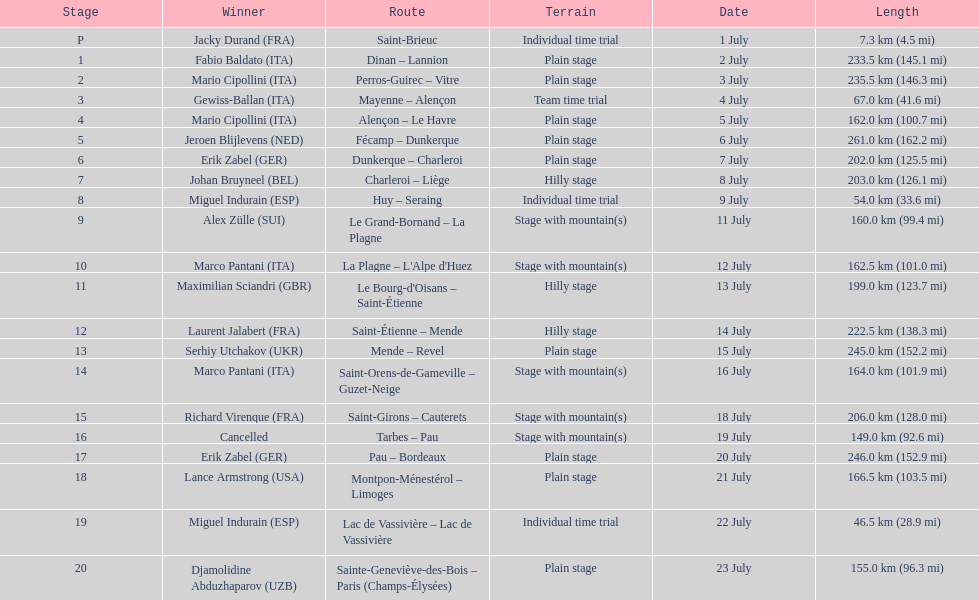After lance armstrong, who led next in the 1995 tour de france? Miguel Indurain. Would you mind parsing the complete table? {'header': ['Stage', 'Winner', 'Route', 'Terrain', 'Date', 'Length'], 'rows': [['P', 'Jacky Durand\xa0(FRA)', 'Saint-Brieuc', 'Individual time trial', '1 July', '7.3\xa0km (4.5\xa0mi)'], ['1', 'Fabio Baldato\xa0(ITA)', 'Dinan – Lannion', 'Plain stage', '2 July', '233.5\xa0km (145.1\xa0mi)'], ['2', 'Mario Cipollini\xa0(ITA)', 'Perros-Guirec – Vitre', 'Plain stage', '3 July', '235.5\xa0km (146.3\xa0mi)'], ['3', 'Gewiss-Ballan\xa0(ITA)', 'Mayenne – Alençon', 'Team time trial', '4 July', '67.0\xa0km (41.6\xa0mi)'], ['4', 'Mario Cipollini\xa0(ITA)', 'Alençon – Le Havre', 'Plain stage', '5 July', '162.0\xa0km (100.7\xa0mi)'], ['5', 'Jeroen Blijlevens\xa0(NED)', 'Fécamp – Dunkerque', 'Plain stage', '6 July', '261.0\xa0km (162.2\xa0mi)'], ['6', 'Erik Zabel\xa0(GER)', 'Dunkerque – Charleroi', 'Plain stage', '7 July', '202.0\xa0km (125.5\xa0mi)'], ['7', 'Johan Bruyneel\xa0(BEL)', 'Charleroi – Liège', 'Hilly stage', '8 July', '203.0\xa0km (126.1\xa0mi)'], ['8', 'Miguel Indurain\xa0(ESP)', 'Huy – Seraing', 'Individual time trial', '9 July', '54.0\xa0km (33.6\xa0mi)'], ['9', 'Alex Zülle\xa0(SUI)', 'Le Grand-Bornand – La Plagne', 'Stage with mountain(s)', '11 July', '160.0\xa0km (99.4\xa0mi)'], ['10', 'Marco Pantani\xa0(ITA)', "La Plagne – L'Alpe d'Huez", 'Stage with mountain(s)', '12 July', '162.5\xa0km (101.0\xa0mi)'], ['11', 'Maximilian Sciandri\xa0(GBR)', "Le Bourg-d'Oisans – Saint-Étienne", 'Hilly stage', '13 July', '199.0\xa0km (123.7\xa0mi)'], ['12', 'Laurent Jalabert\xa0(FRA)', 'Saint-Étienne – Mende', 'Hilly stage', '14 July', '222.5\xa0km (138.3\xa0mi)'], ['13', 'Serhiy Utchakov\xa0(UKR)', 'Mende – Revel', 'Plain stage', '15 July', '245.0\xa0km (152.2\xa0mi)'], ['14', 'Marco Pantani\xa0(ITA)', 'Saint-Orens-de-Gameville – Guzet-Neige', 'Stage with mountain(s)', '16 July', '164.0\xa0km (101.9\xa0mi)'], ['15', 'Richard Virenque\xa0(FRA)', 'Saint-Girons – Cauterets', 'Stage with mountain(s)', '18 July', '206.0\xa0km (128.0\xa0mi)'], ['16', 'Cancelled', 'Tarbes – Pau', 'Stage with mountain(s)', '19 July', '149.0\xa0km (92.6\xa0mi)'], ['17', 'Erik Zabel\xa0(GER)', 'Pau – Bordeaux', 'Plain stage', '20 July', '246.0\xa0km (152.9\xa0mi)'], ['18', 'Lance Armstrong\xa0(USA)', 'Montpon-Ménestérol – Limoges', 'Plain stage', '21 July', '166.5\xa0km (103.5\xa0mi)'], ['19', 'Miguel Indurain\xa0(ESP)', 'Lac de Vassivière – Lac de Vassivière', 'Individual time trial', '22 July', '46.5\xa0km (28.9\xa0mi)'], ['20', 'Djamolidine Abduzhaparov\xa0(UZB)', 'Sainte-Geneviève-des-Bois – Paris (Champs-Élysées)', 'Plain stage', '23 July', '155.0\xa0km (96.3\xa0mi)']]} 